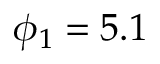<formula> <loc_0><loc_0><loc_500><loc_500>\phi _ { 1 } = 5 . 1</formula> 